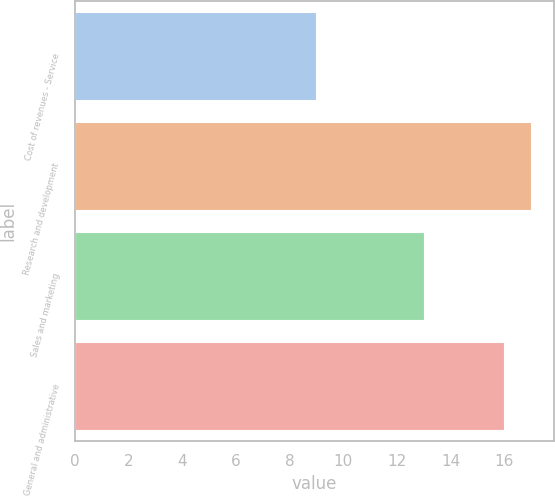<chart> <loc_0><loc_0><loc_500><loc_500><bar_chart><fcel>Cost of revenues - Service<fcel>Research and development<fcel>Sales and marketing<fcel>General and administrative<nl><fcel>9<fcel>17<fcel>13<fcel>16<nl></chart> 